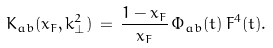Convert formula to latex. <formula><loc_0><loc_0><loc_500><loc_500>K _ { a b } ( x _ { F } , k ^ { 2 } _ { \bot } ) \, = \, \frac { 1 - x _ { F } } { x _ { F } } \, \Phi _ { a b } ( t ) \, F ^ { 4 } ( t ) .</formula> 